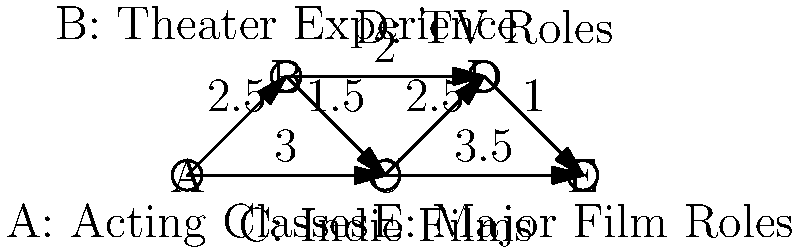In the entertainment industry career graph above, nodes represent different career stages, and edges represent potential career paths with associated costs (in years). What is the minimum total time required to progress from acting classes (A) to major film roles (E) while gaining experience in all areas? To solve this problem, we need to find the minimum spanning tree (MST) of the graph. The MST will represent the most efficient path through all career stages. We'll use Kruskal's algorithm to find the MST:

1. Sort all edges by weight (cost in years):
   (D,E): 1.0
   (B,C): 1.5
   (B,D): 2.0
   (A,B): 2.5
   (C,D): 2.5
   (A,C): 3.0
   (C,E): 3.5

2. Start with an empty set of edges and add edges in order of increasing weight, skipping those that would create a cycle:
   - Add (D,E): 1.0
   - Add (B,C): 1.5
   - Add (B,D): 2.0
   - Add (A,B): 2.5

3. The MST is now complete with 4 edges (for 5 nodes).

4. Sum the weights of the edges in the MST:
   1.0 + 1.5 + 2.0 + 2.5 = 7.0

Therefore, the minimum total time required to progress through all career stages from acting classes (A) to major film roles (E) is 7.0 years.
Answer: 7.0 years 